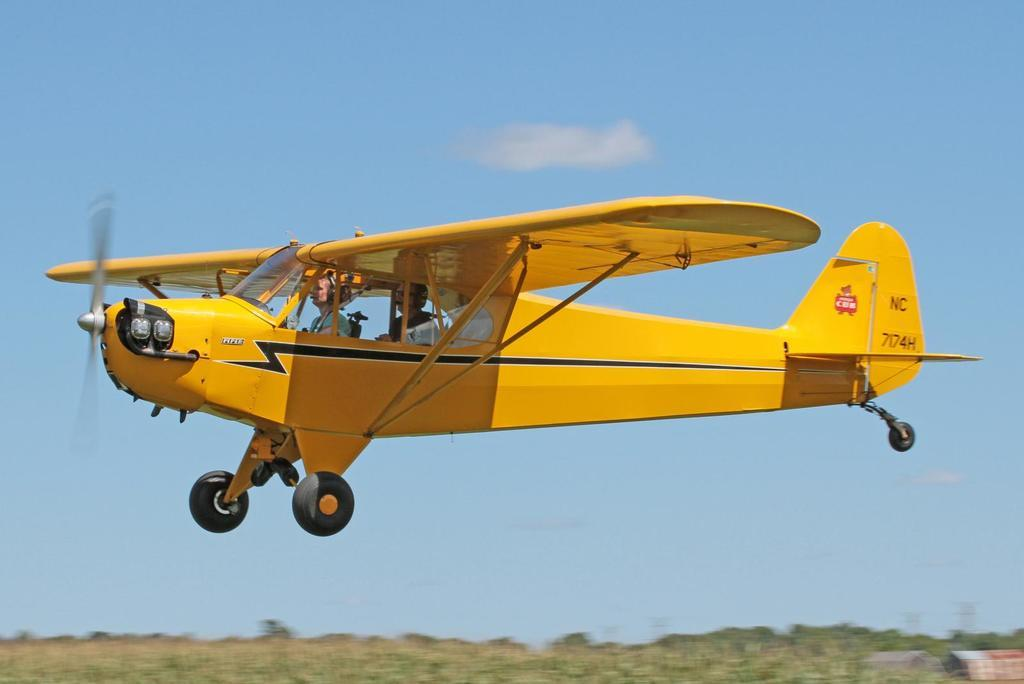How many people are inside the monoplane in the image? There are two people sitting inside the monoplane in the image. What is the position of the monoplane in the image? The monoplane is in the air in the image. What type of structures can be seen in the image? There are houses visible in the image. What type of vegetation is present in the image? There are trees in the image. What is visible in the background of the image? The sky is visible in the background of the image. What type of coal is being used to fuel the monoplane in the image? There is no coal present in the image, and the monoplane is not shown to be using any fuel source. 